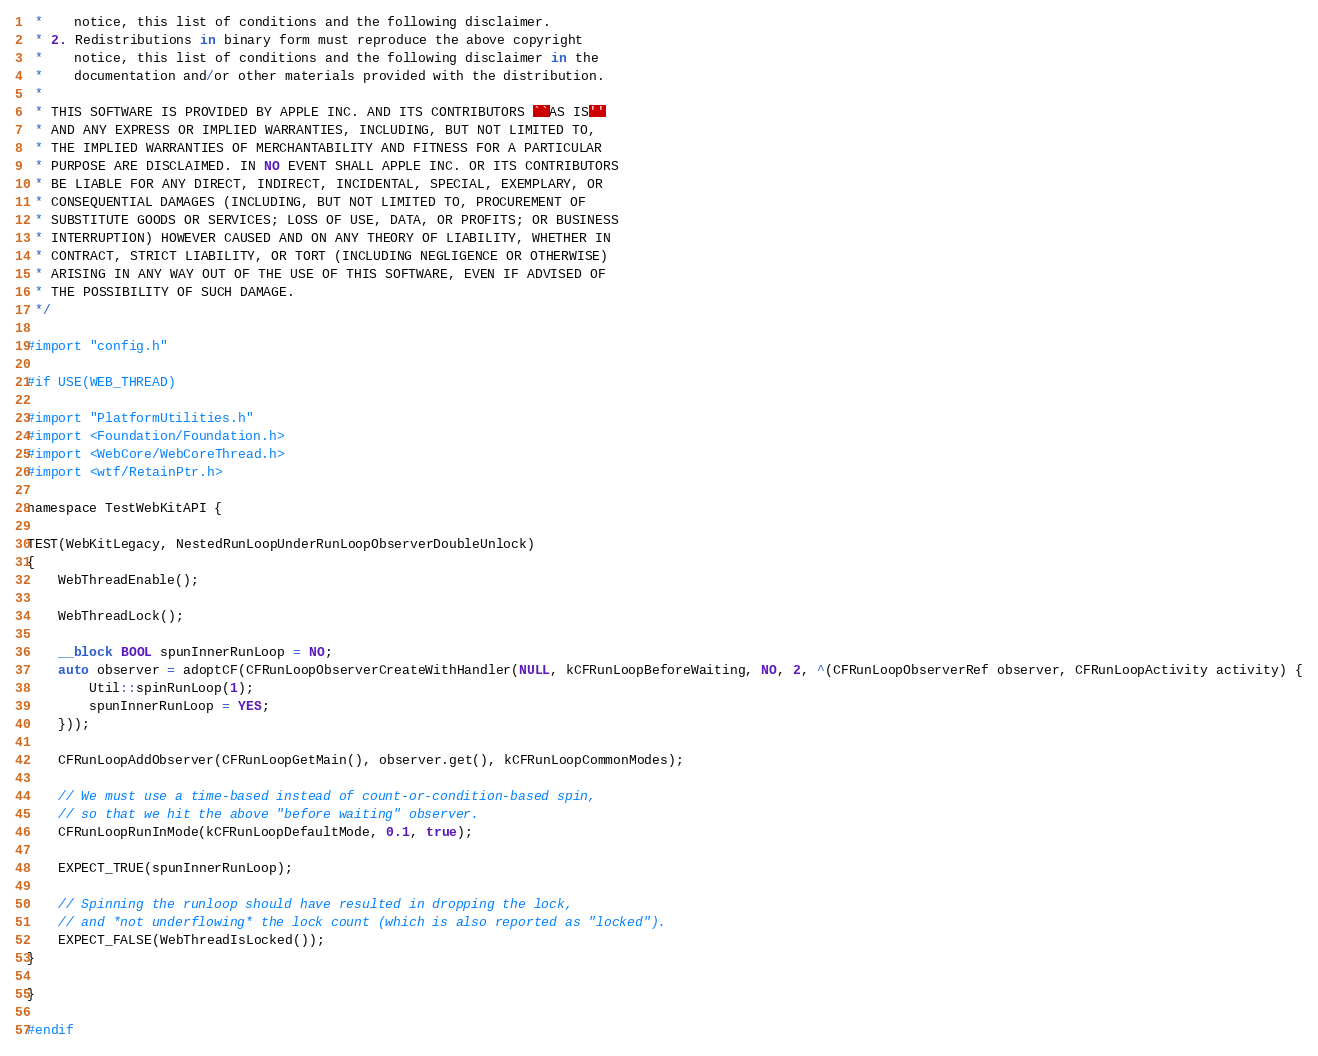<code> <loc_0><loc_0><loc_500><loc_500><_ObjectiveC_> *    notice, this list of conditions and the following disclaimer.
 * 2. Redistributions in binary form must reproduce the above copyright
 *    notice, this list of conditions and the following disclaimer in the
 *    documentation and/or other materials provided with the distribution.
 *
 * THIS SOFTWARE IS PROVIDED BY APPLE INC. AND ITS CONTRIBUTORS ``AS IS''
 * AND ANY EXPRESS OR IMPLIED WARRANTIES, INCLUDING, BUT NOT LIMITED TO,
 * THE IMPLIED WARRANTIES OF MERCHANTABILITY AND FITNESS FOR A PARTICULAR
 * PURPOSE ARE DISCLAIMED. IN NO EVENT SHALL APPLE INC. OR ITS CONTRIBUTORS
 * BE LIABLE FOR ANY DIRECT, INDIRECT, INCIDENTAL, SPECIAL, EXEMPLARY, OR
 * CONSEQUENTIAL DAMAGES (INCLUDING, BUT NOT LIMITED TO, PROCUREMENT OF
 * SUBSTITUTE GOODS OR SERVICES; LOSS OF USE, DATA, OR PROFITS; OR BUSINESS
 * INTERRUPTION) HOWEVER CAUSED AND ON ANY THEORY OF LIABILITY, WHETHER IN
 * CONTRACT, STRICT LIABILITY, OR TORT (INCLUDING NEGLIGENCE OR OTHERWISE)
 * ARISING IN ANY WAY OUT OF THE USE OF THIS SOFTWARE, EVEN IF ADVISED OF
 * THE POSSIBILITY OF SUCH DAMAGE.
 */

#import "config.h"

#if USE(WEB_THREAD)

#import "PlatformUtilities.h"
#import <Foundation/Foundation.h>
#import <WebCore/WebCoreThread.h>
#import <wtf/RetainPtr.h>

namespace TestWebKitAPI {

TEST(WebKitLegacy, NestedRunLoopUnderRunLoopObserverDoubleUnlock)
{
    WebThreadEnable();

    WebThreadLock();
    
    __block BOOL spunInnerRunLoop = NO;
    auto observer = adoptCF(CFRunLoopObserverCreateWithHandler(NULL, kCFRunLoopBeforeWaiting, NO, 2, ^(CFRunLoopObserverRef observer, CFRunLoopActivity activity) {
        Util::spinRunLoop(1);
        spunInnerRunLoop = YES;
    }));

    CFRunLoopAddObserver(CFRunLoopGetMain(), observer.get(), kCFRunLoopCommonModes);

    // We must use a time-based instead of count-or-condition-based spin,
    // so that we hit the above "before waiting" observer.
    CFRunLoopRunInMode(kCFRunLoopDefaultMode, 0.1, true);
    
    EXPECT_TRUE(spunInnerRunLoop);
    
    // Spinning the runloop should have resulted in dropping the lock,
    // and *not underflowing* the lock count (which is also reported as "locked").
    EXPECT_FALSE(WebThreadIsLocked());
}

}

#endif
</code> 